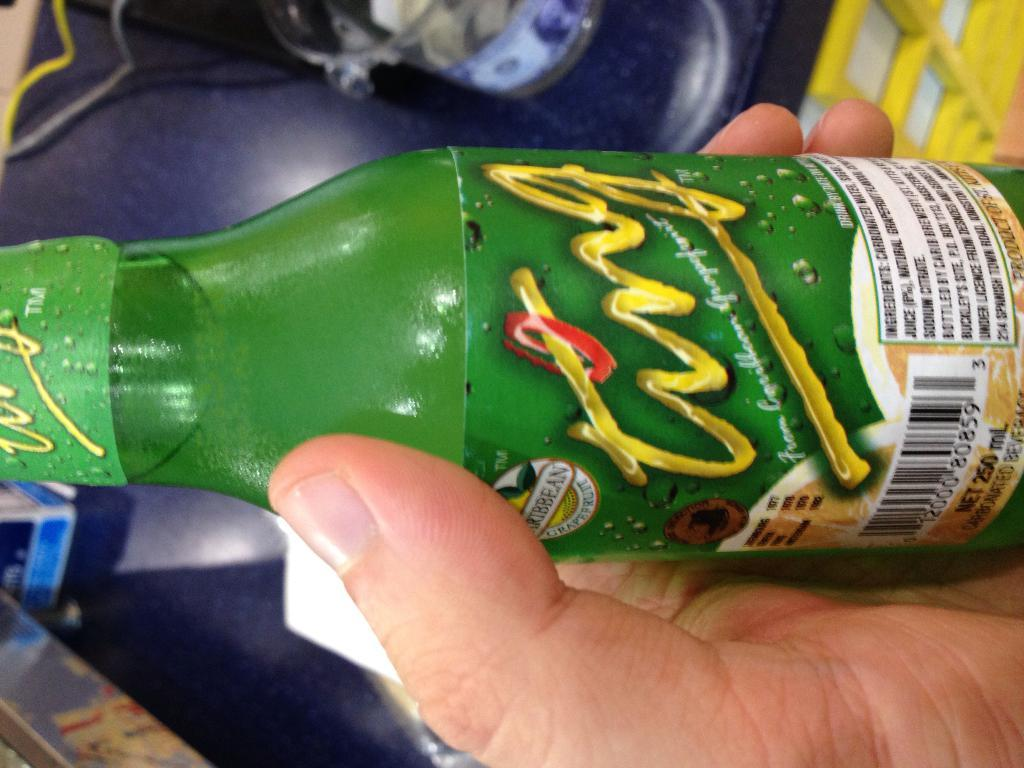What is present in the image that belongs to a person? There is a hand in the image that belongs to a person. What is the hand holding? The person's hand is holding a bottle. What type of grain can be seen growing in the image? There is no grain present in the image; it features a hand holding a bottle. How many cattle are visible in the image? There are no cattle present in the image. 